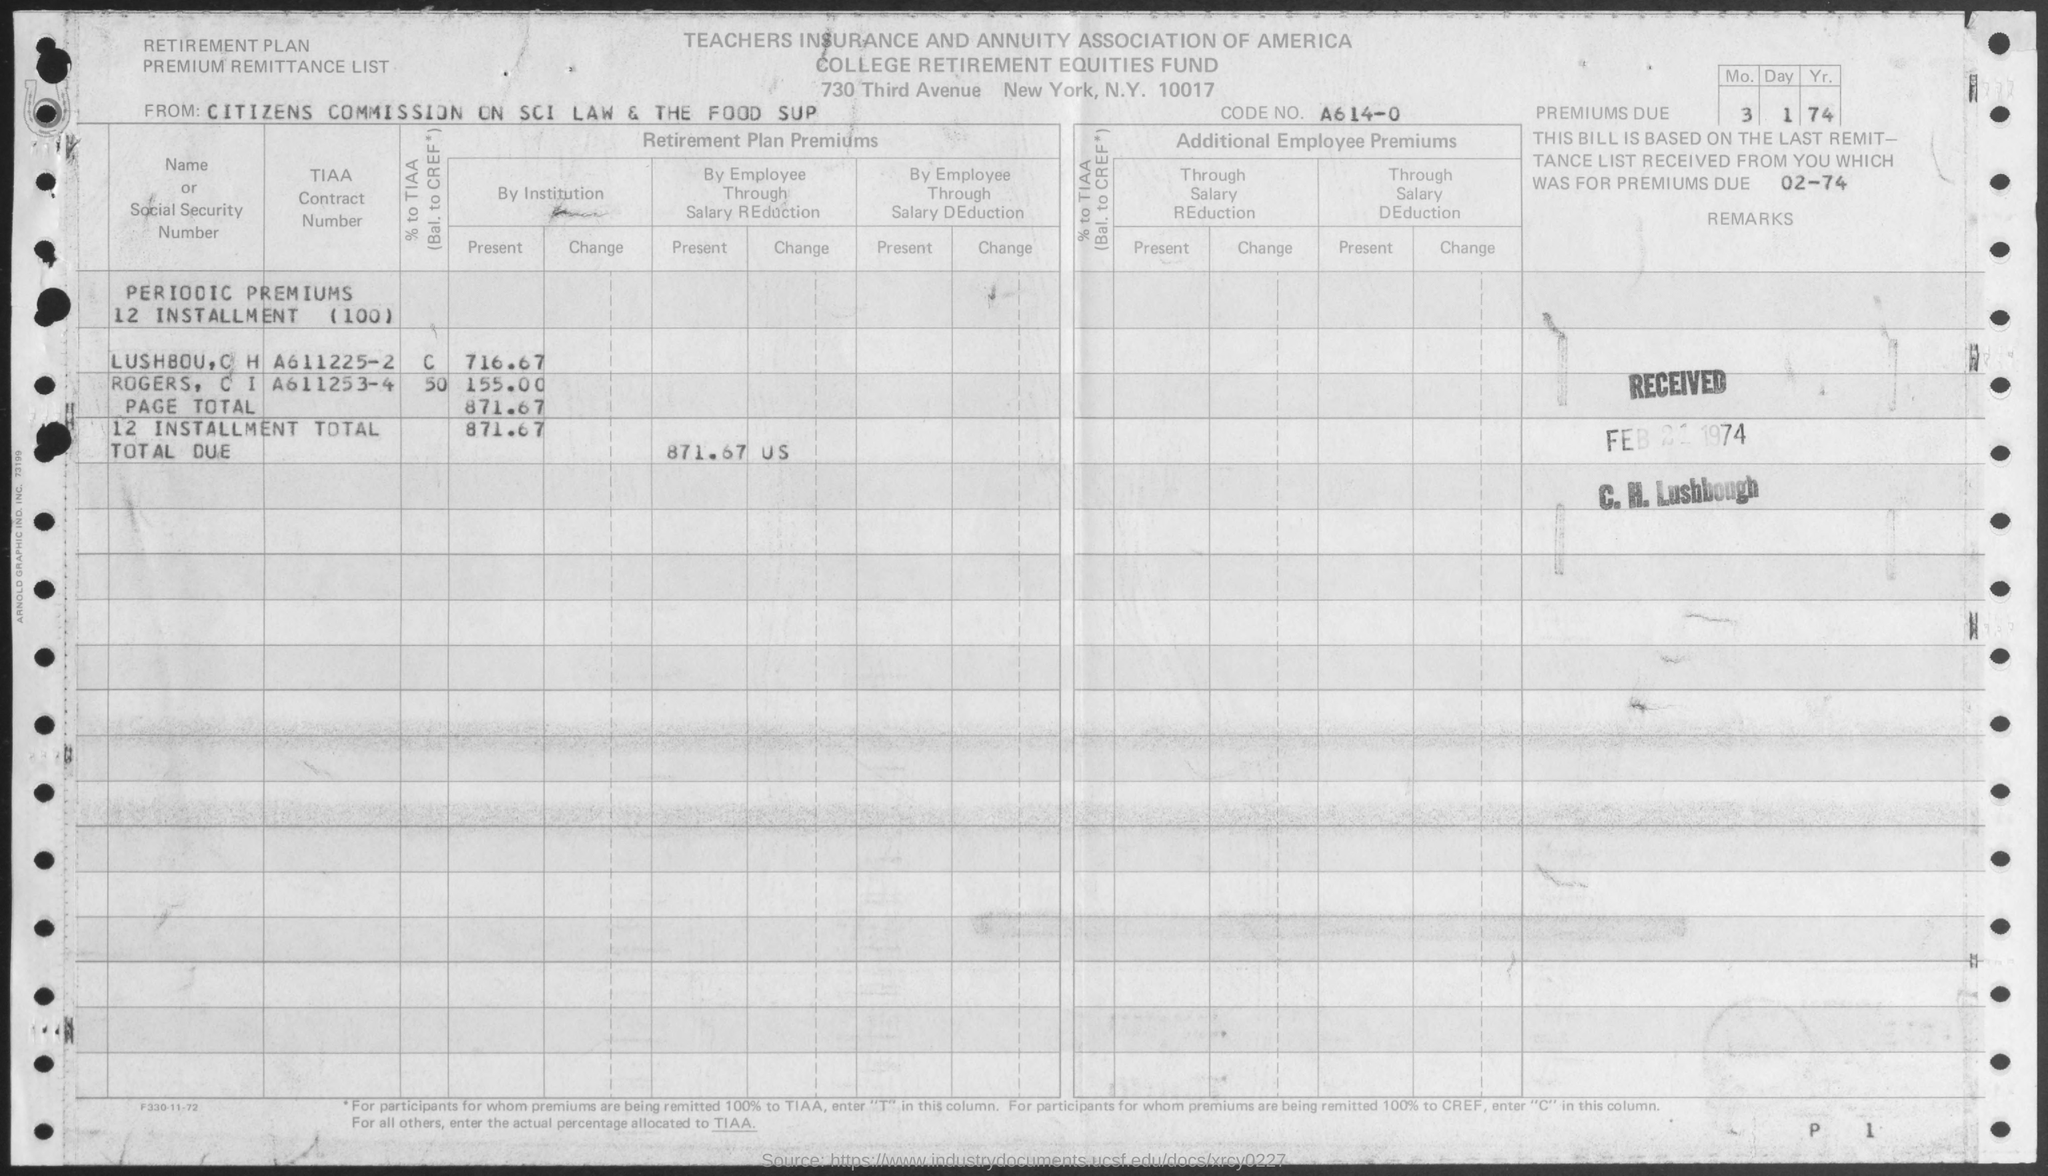Give some essential details in this illustration. The document is from the Citizens Commission on SCI Law and The Food Supply. The CODE NO. is A614-0.... The total due is 871.67 USD. 